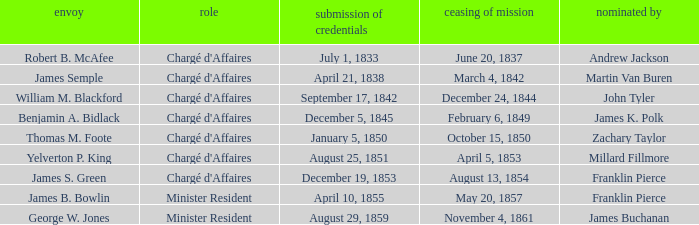What Title has a Termination of Mission of November 4, 1861? Minister Resident. 